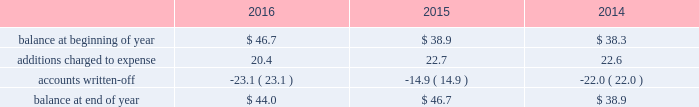Republic services , inc .
Notes to consolidated financial statements 2014 ( continued ) high quality financial institutions .
Such balances may be in excess of fdic insured limits .
To manage the related credit exposure , we continually monitor the credit worthiness of the financial institutions where we have deposits .
Concentrations of credit risk with respect to trade accounts receivable are limited due to the wide variety of customers and markets in which we provide services , as well as the dispersion of our operations across many geographic areas .
We provide services to small-container commercial , large-container industrial , municipal and residential customers in the united states and puerto rico .
We perform ongoing credit evaluations of our customers , but generally do not require collateral to support customer receivables .
We establish an allowance for doubtful accounts based on various factors including the credit risk of specific customers , age of receivables outstanding , historical trends , economic conditions and other information .
Accounts receivable , net accounts receivable represent receivables from customers for collection , transfer , recycling , disposal , energy services and other services .
Our receivables are recorded when billed or when the related revenue is earned , if earlier , and represent claims against third parties that will be settled in cash .
The carrying value of our receivables , net of the allowance for doubtful accounts and customer credits , represents their estimated net realizable value .
Provisions for doubtful accounts are evaluated on a monthly basis and are recorded based on our historical collection experience , the age of the receivables , specific customer information and economic conditions .
We also review outstanding balances on an account-specific basis .
In general , reserves are provided for accounts receivable in excess of 90 days outstanding .
Past due receivable balances are written-off when our collection efforts have been unsuccessful in collecting amounts due .
The table reflects the activity in our allowance for doubtful accounts for the years ended december 31: .
Restricted cash and marketable securities as of december 31 , 2016 , we had $ 90.5 million of restricted cash and marketable securities of which $ 62.6 million supports our insurance programs for workers 2019 compensation , commercial general liability , and commercial auto liability .
Additionally , we obtain funds through the issuance of tax-exempt bonds for the purpose of financing qualifying expenditures at our landfills , transfer stations , collection and recycling centers .
The funds are deposited directly into trust accounts by the bonding authorities at the time of issuance .
As the use of these funds is contractually restricted , and we do not have the ability to use these funds for general operating purposes , they are classified as restricted cash and marketable securities in our consolidated balance sheets .
In the normal course of business , we may be required to provide financial assurance to governmental agencies and a variety of other entities in connection with municipal residential collection contracts , closure or post- closure of landfills , environmental remediation , environmental permits , and business licenses and permits as a financial guarantee of our performance .
At several of our landfills , we satisfy financial assurance requirements by depositing cash into restricted trust funds or escrow accounts .
Property and equipment we record property and equipment at cost .
Expenditures for major additions and improvements to facilities are capitalized , while maintenance and repairs are charged to expense as incurred .
When property is retired or .
What was the percentage change in the allowance for doubtful accounts in 2016? 
Rationale: the was a decline in the allowance for doubtful accounts in 2016 by 5.8%
Computations: ((44.0 - 46.7) / 46.7)
Answer: -0.05782. 